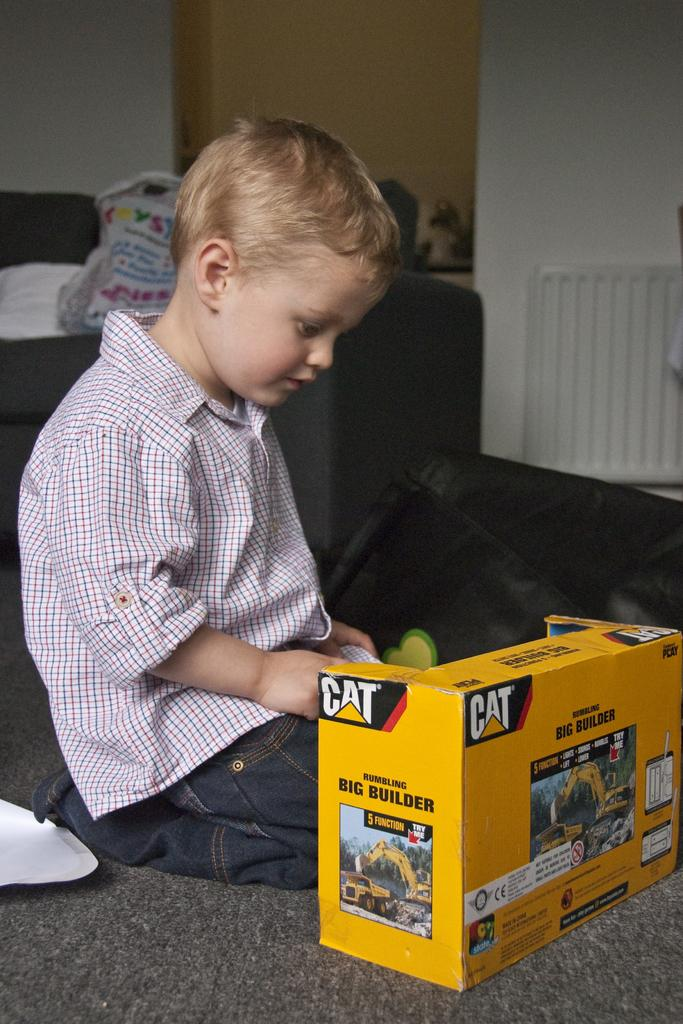<image>
Share a concise interpretation of the image provided. A child sitting on the floor opening a box that contains a CAT brand name toy. 